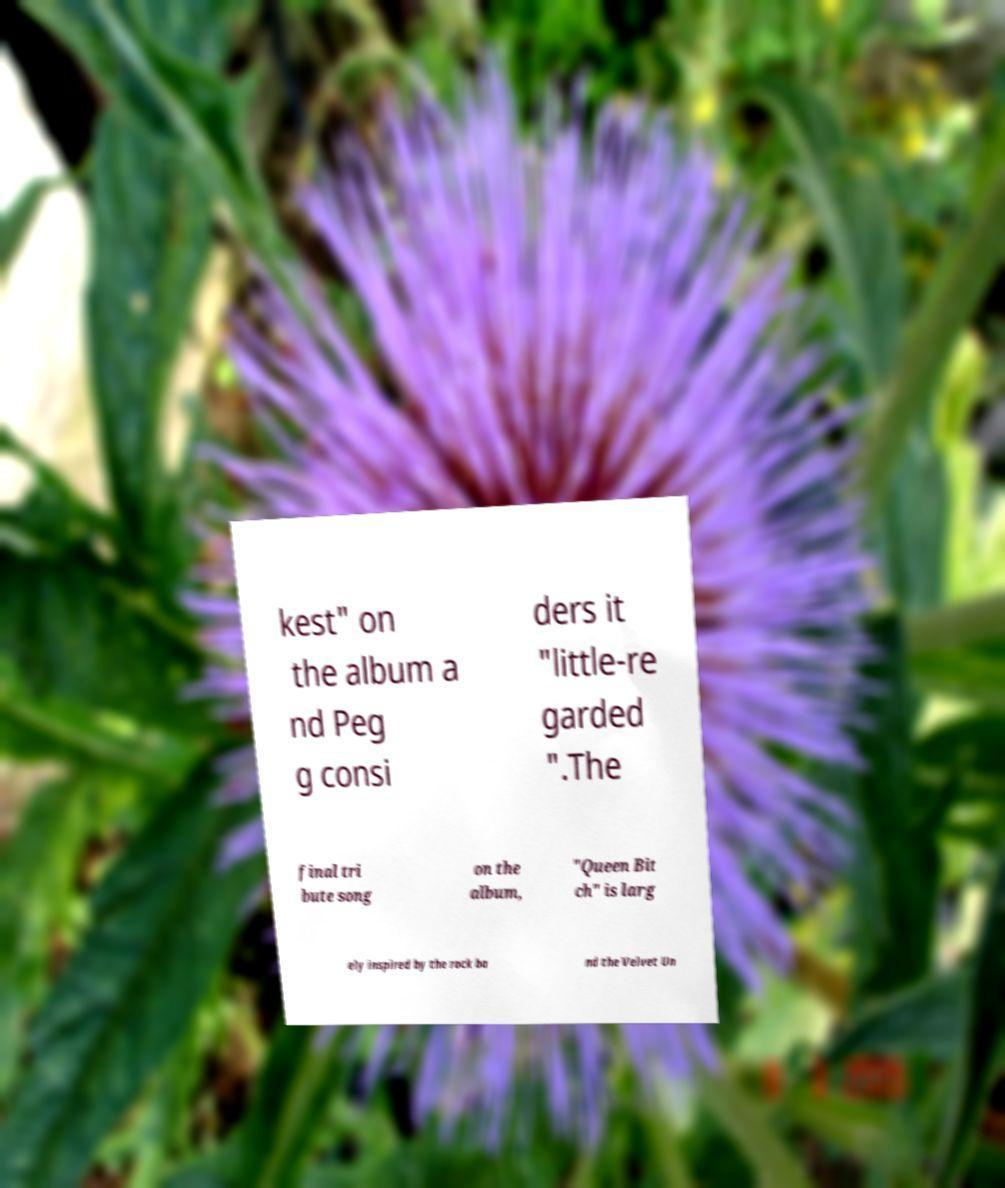I need the written content from this picture converted into text. Can you do that? kest" on the album a nd Peg g consi ders it "little-re garded ".The final tri bute song on the album, "Queen Bit ch" is larg ely inspired by the rock ba nd the Velvet Un 